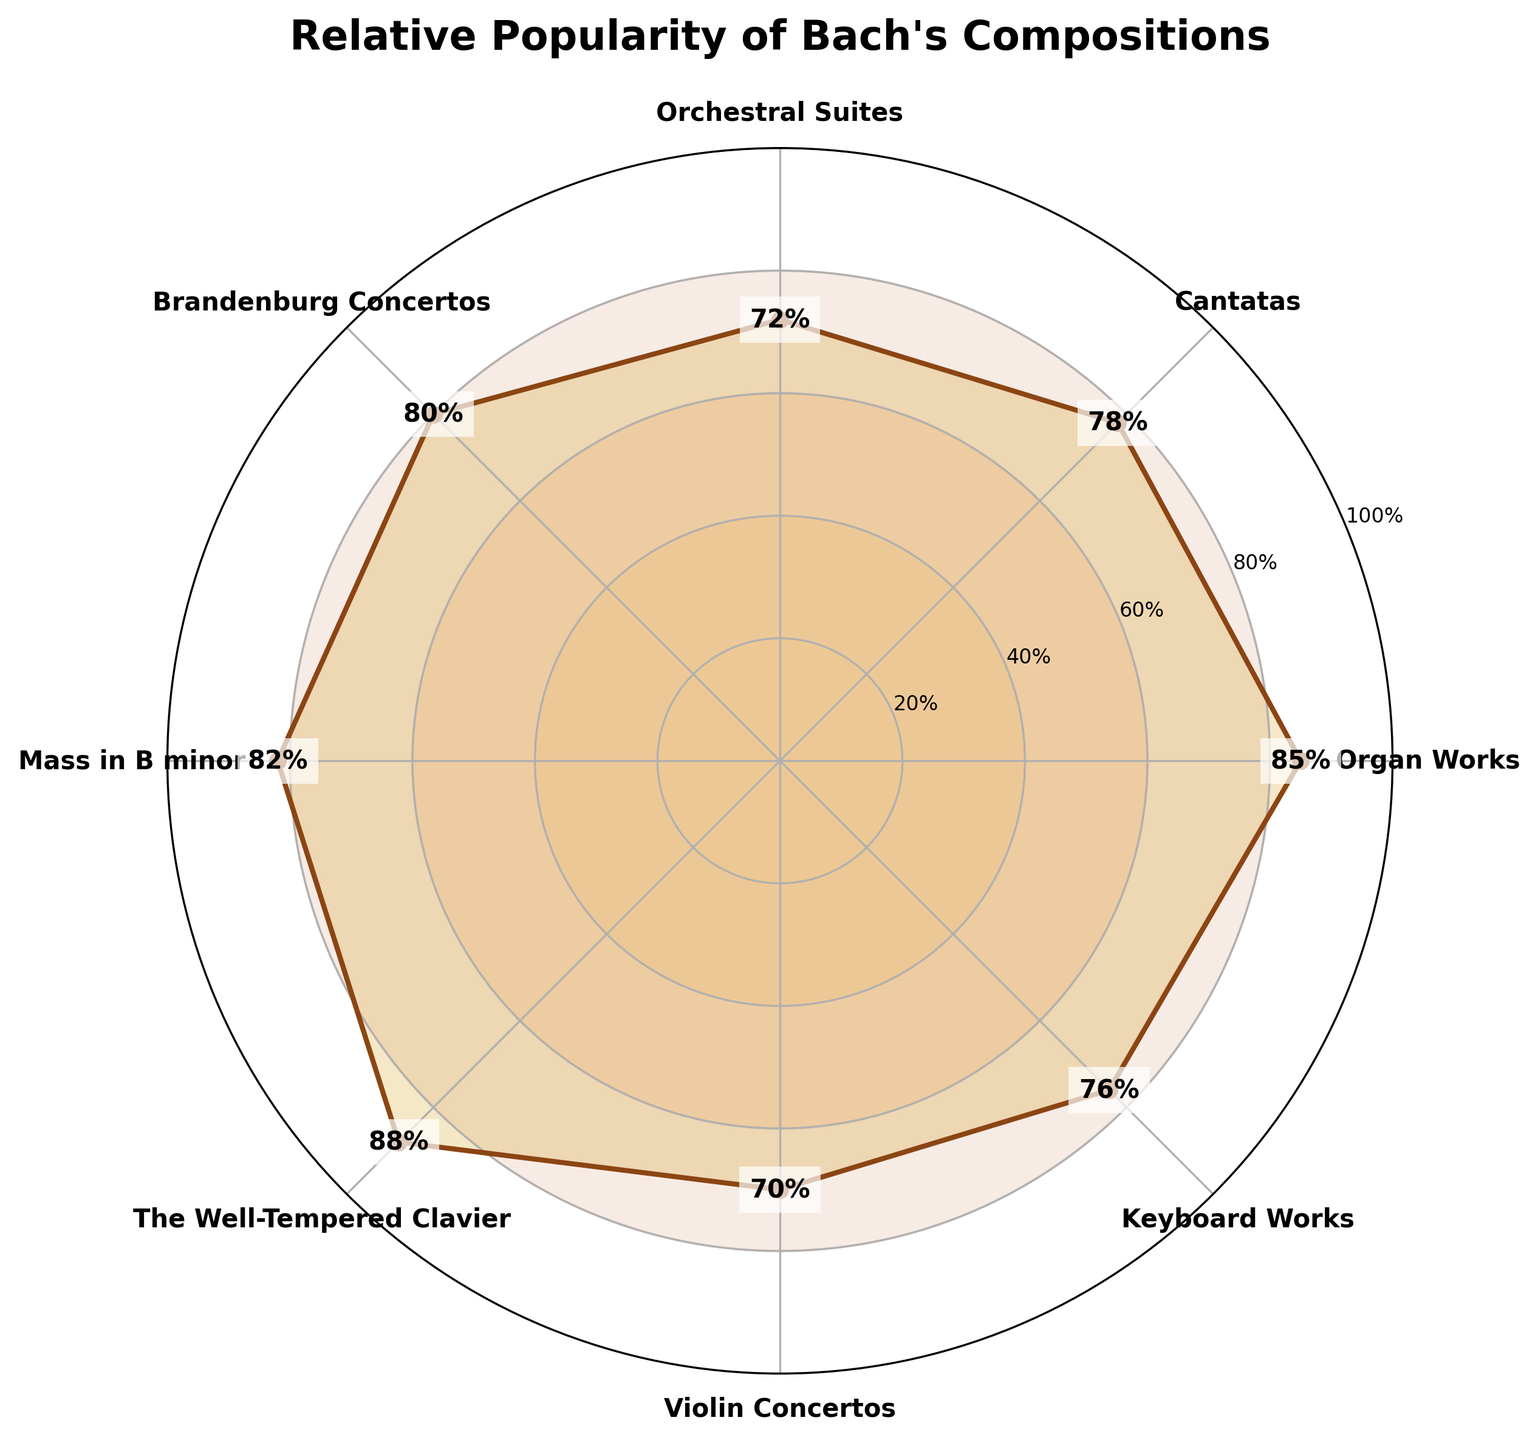what is the title of the plot? The title of the plot is displayed at the top of the figure. It summarizes the subject of the figure, which is the relative popularity of Bach's compositions.
Answer: Relative Popularity of Bach's Compositions How many different types of compositions are shown in the plot? The figure shows annotations at different angles corresponding to different types of compositions. Counting these annotations gives the total number of composition types.
Answer: 8 Which composition has the highest popularity score? The composition with the highest popularity score corresponds to the peak point on the radial plot and is labeled with its value for verification.
Answer: The Well-Tempered Clavier Is the popularity of the Organ Works higher or lower than the Violin Concertos? By comparing the radial distances for Organ Works and Violin Concertos, we can determine which is higher.
Answer: Higher What is the average popularity score of all compositions? Sum up all popularity scores and then divide by the number of compositions to find the average. (85+78+72+80+82+88+70+76)/8 = 79.875
Answer: 79.875 Which compositions have a popularity score greater than 80? Identify the compositions whose values exceed 80 by examining their annotations on the radial plot.
Answer: Organ Works, Brandenburg Concertos, Mass in B minor, The Well-Tempered Clavier What is the difference in popularity score between the highest and lowest compositions? Find the difference between the highest (88) and lowest (70) popularity scores by simple subtraction.
Answer: 18 Which composition type has a popularity score closest to that of the Organ Works? Compare the popularity scores for the Organ Works against all other compositions and find the one with the smallest difference.
Answer: Mass in B minor 